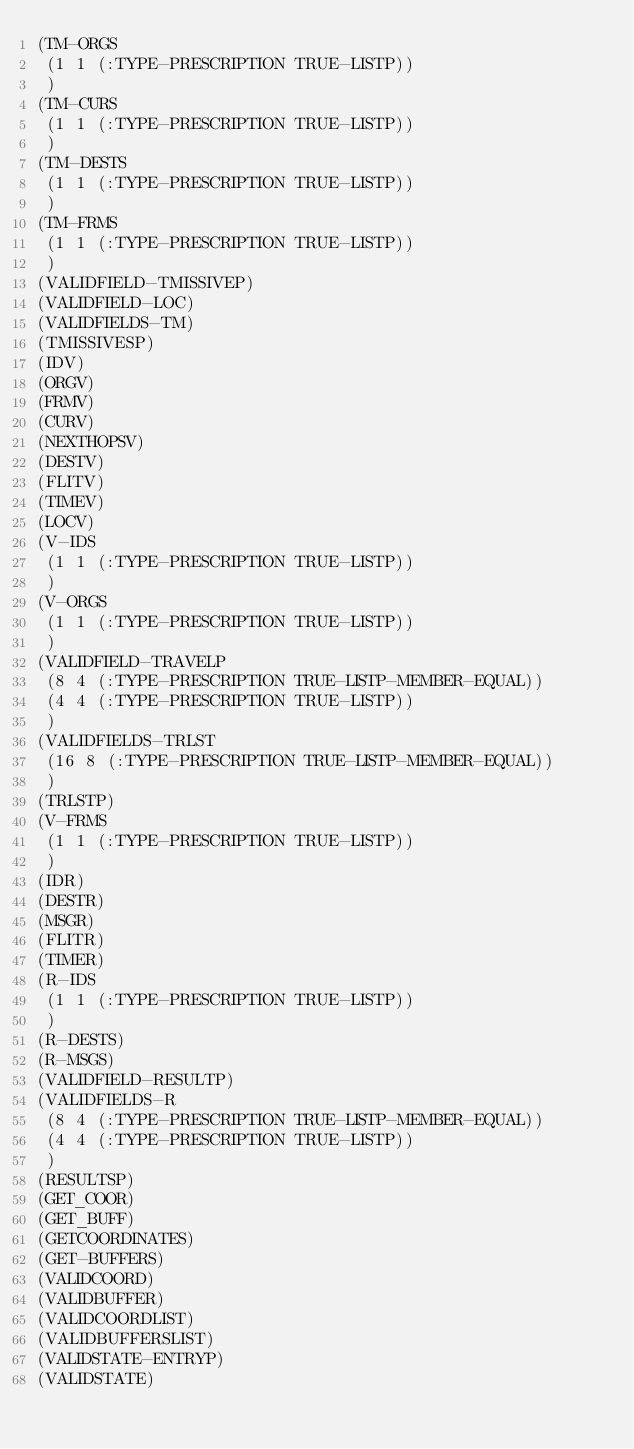<code> <loc_0><loc_0><loc_500><loc_500><_Lisp_>(TM-ORGS
 (1 1 (:TYPE-PRESCRIPTION TRUE-LISTP))
 )
(TM-CURS
 (1 1 (:TYPE-PRESCRIPTION TRUE-LISTP))
 )
(TM-DESTS
 (1 1 (:TYPE-PRESCRIPTION TRUE-LISTP))
 )
(TM-FRMS
 (1 1 (:TYPE-PRESCRIPTION TRUE-LISTP))
 )
(VALIDFIELD-TMISSIVEP)
(VALIDFIELD-LOC)
(VALIDFIELDS-TM)
(TMISSIVESP)
(IDV)
(ORGV)
(FRMV)
(CURV)
(NEXTHOPSV)
(DESTV)
(FLITV)
(TIMEV)
(LOCV)
(V-IDS
 (1 1 (:TYPE-PRESCRIPTION TRUE-LISTP))
 )
(V-ORGS
 (1 1 (:TYPE-PRESCRIPTION TRUE-LISTP))
 )
(VALIDFIELD-TRAVELP
 (8 4 (:TYPE-PRESCRIPTION TRUE-LISTP-MEMBER-EQUAL))
 (4 4 (:TYPE-PRESCRIPTION TRUE-LISTP))
 )
(VALIDFIELDS-TRLST
 (16 8 (:TYPE-PRESCRIPTION TRUE-LISTP-MEMBER-EQUAL))
 )
(TRLSTP)
(V-FRMS
 (1 1 (:TYPE-PRESCRIPTION TRUE-LISTP))
 )
(IDR)
(DESTR)
(MSGR)
(FLITR)
(TIMER)
(R-IDS
 (1 1 (:TYPE-PRESCRIPTION TRUE-LISTP))
 )
(R-DESTS)
(R-MSGS)
(VALIDFIELD-RESULTP)
(VALIDFIELDS-R
 (8 4 (:TYPE-PRESCRIPTION TRUE-LISTP-MEMBER-EQUAL))
 (4 4 (:TYPE-PRESCRIPTION TRUE-LISTP))
 )
(RESULTSP)
(GET_COOR)
(GET_BUFF)
(GETCOORDINATES)
(GET-BUFFERS)
(VALIDCOORD)
(VALIDBUFFER)
(VALIDCOORDLIST)
(VALIDBUFFERSLIST)
(VALIDSTATE-ENTRYP)
(VALIDSTATE)
</code> 